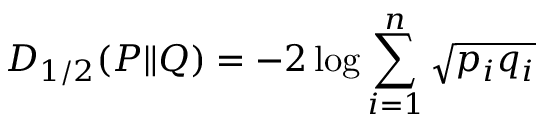<formula> <loc_0><loc_0><loc_500><loc_500>D _ { 1 / 2 } ( P \| Q ) = - 2 \log \sum _ { i = 1 } ^ { n } { \sqrt { p _ { i } q _ { i } } }</formula> 